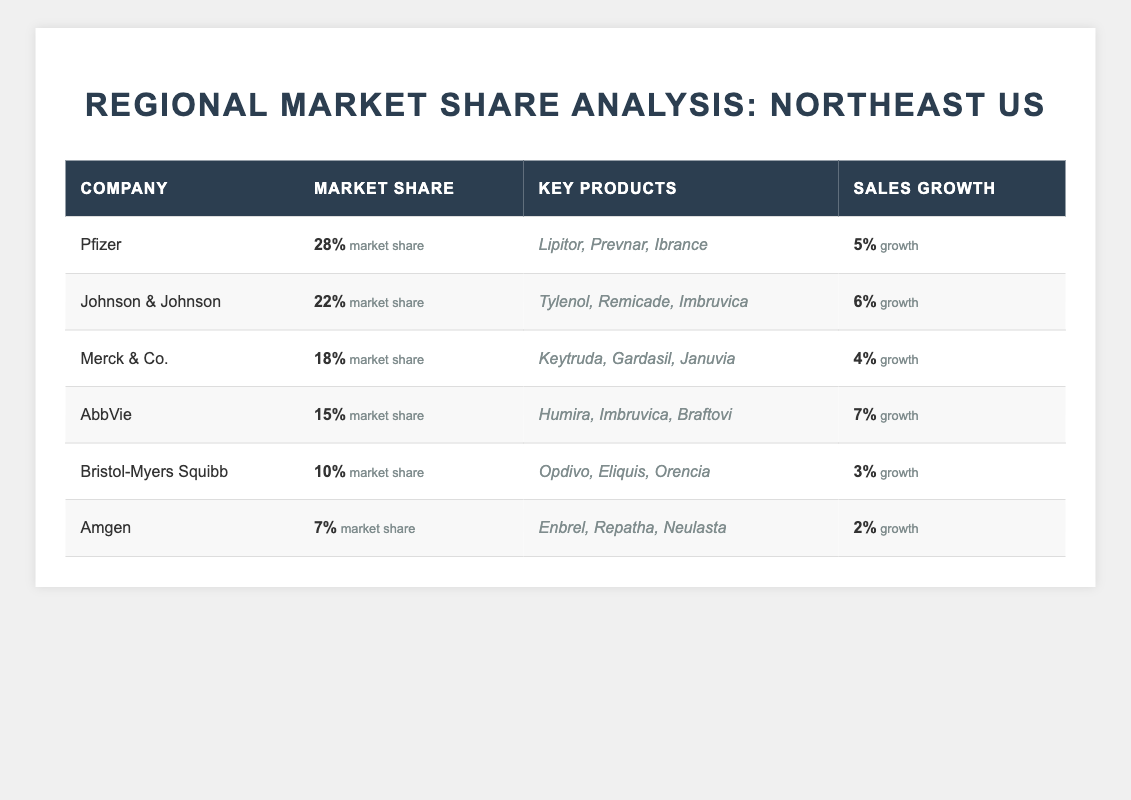What is the market share of Pfizer? The table indicates that Pfizer has a market share of 28%.
Answer: 28% Which company has the lowest market share? By examining the market shares in the table, Amgen has the lowest at 7%.
Answer: Amgen What is the sales growth percentage of Johnson & Johnson? According to the table, Johnson & Johnson has a sales growth of 6%.
Answer: 6% How much higher is AbbVie's market share compared to Bristol-Myers Squibb's? AbbVie has a market share of 15% and Bristol-Myers Squibb has 10%, resulting in a difference of 5%.
Answer: 5% Which two companies have a sales growth greater than 5%? Both AbbVie (7%) and Johnson & Johnson (6%) have sales growth greater than 5%.
Answer: AbbVie and Johnson & Johnson What is the average market share of all the companies listed? To find the average: (28 + 22 + 18 + 15 + 10 + 7) / 6 = 100 / 6 ≈ 16.67%.
Answer: 16.67% Is Merck & Co.'s market share greater than 20%? Merck & Co. has a market share of 18%, which is not greater than 20%.
Answer: No What is the total market share of the top three companies? The market shares of the top three companies (Pfizer, Johnson & Johnson, and Merck & Co.) are 28%, 22%, and 18%, totaling 28 + 22 + 18 = 68%.
Answer: 68% Which company has both the highest market share and lowest sales growth percentage? Pfizer has the highest market share at 28%, but the lowest sales growth is 2% by Amgen.
Answer: Amgen How do AbbVie's and Merck & Co.'s sales growth percentages compare? AbbVie has a sales growth of 7%, while Merck & Co. has 4%, making AbbVie's growth higher by 3%.
Answer: 3% higher 